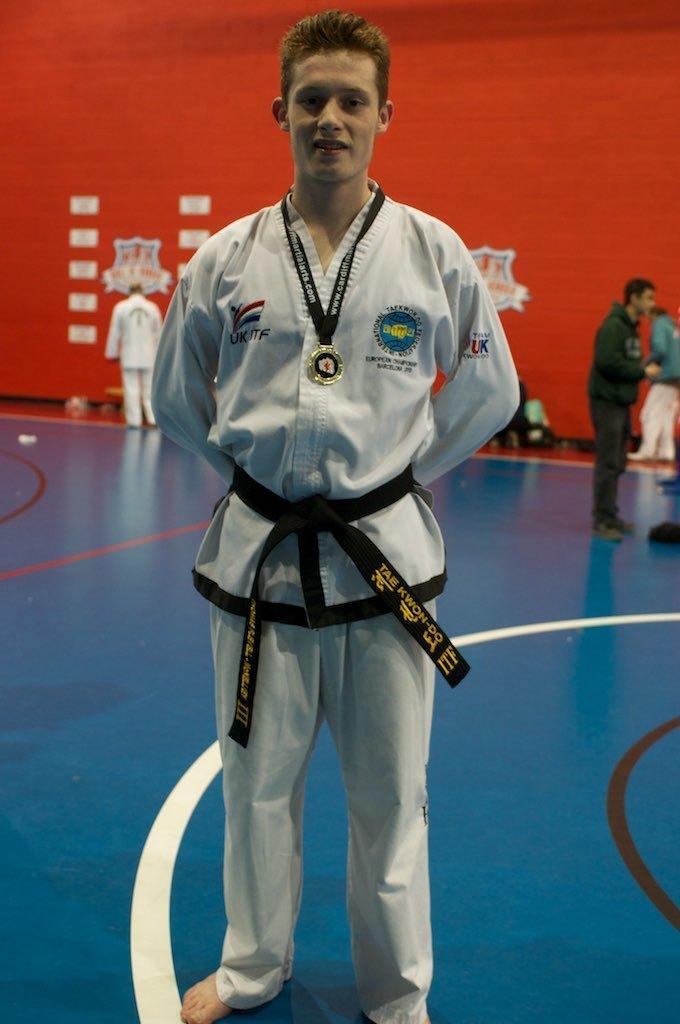Please provide a concise description of this image. In this image we can see a person is standing, he is wearing karate suit and one meddle is there in his neck. The floor is in blue color. The wall is in white color. Behind people are standing. 